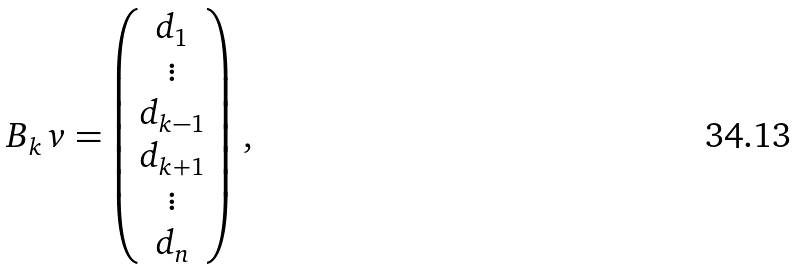<formula> <loc_0><loc_0><loc_500><loc_500>B _ { k } \, v = \begin{pmatrix} d _ { 1 } \\ \vdots \\ d _ { k - 1 } \\ d _ { k + 1 } \\ \vdots \\ d _ { n } \end{pmatrix} \, ,</formula> 